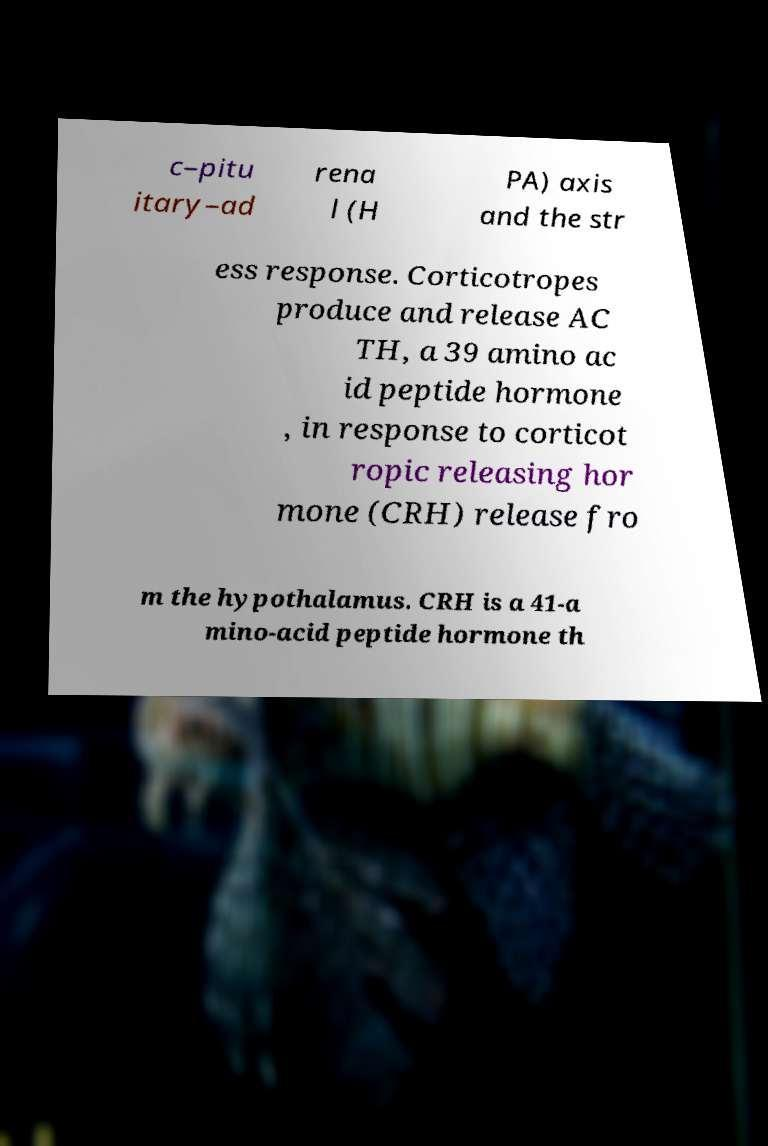Can you accurately transcribe the text from the provided image for me? c–pitu itary–ad rena l (H PA) axis and the str ess response. Corticotropes produce and release AC TH, a 39 amino ac id peptide hormone , in response to corticot ropic releasing hor mone (CRH) release fro m the hypothalamus. CRH is a 41-a mino-acid peptide hormone th 